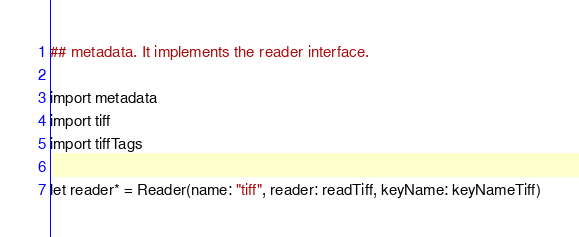<code> <loc_0><loc_0><loc_500><loc_500><_Nim_>## metadata. It implements the reader interface.

import metadata
import tiff
import tiffTags

let reader* = Reader(name: "tiff", reader: readTiff, keyName: keyNameTiff)
</code> 